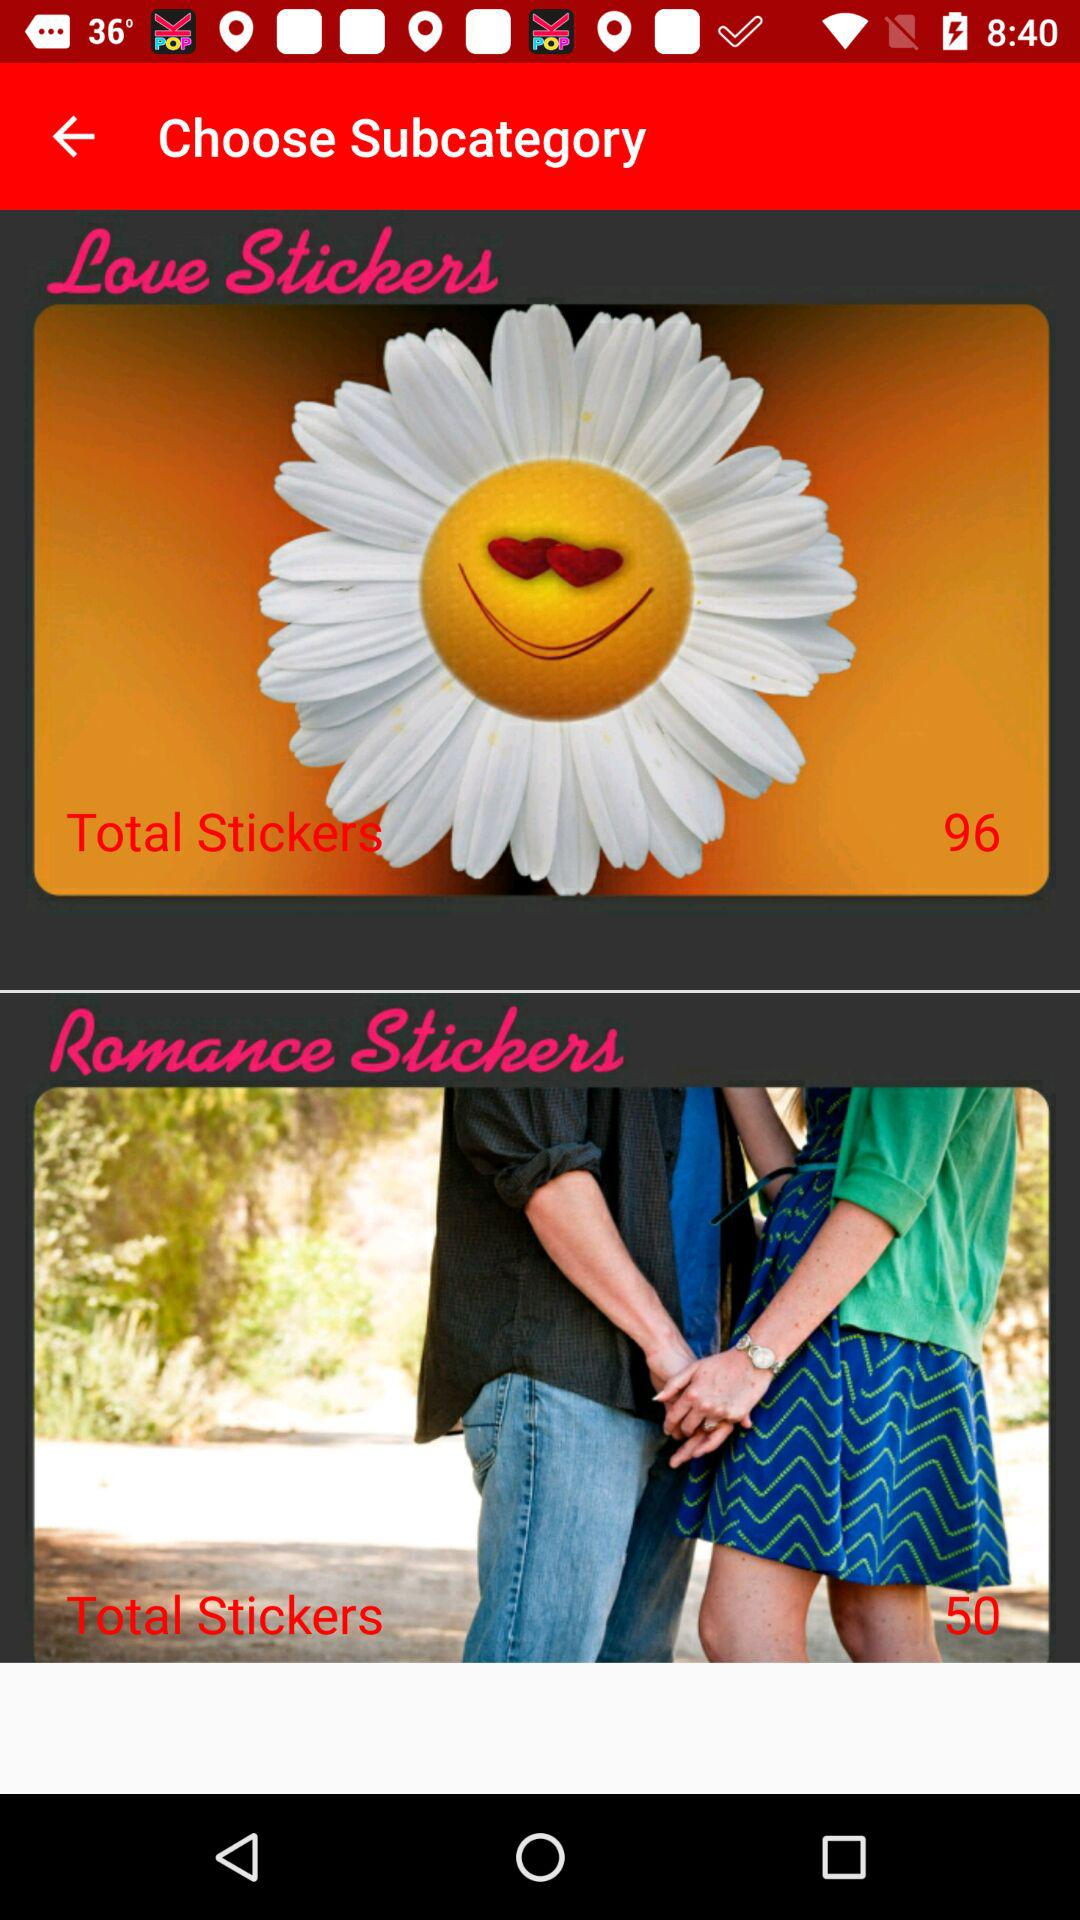What is the total number of love stickers? The total number of love stickers is 96. 